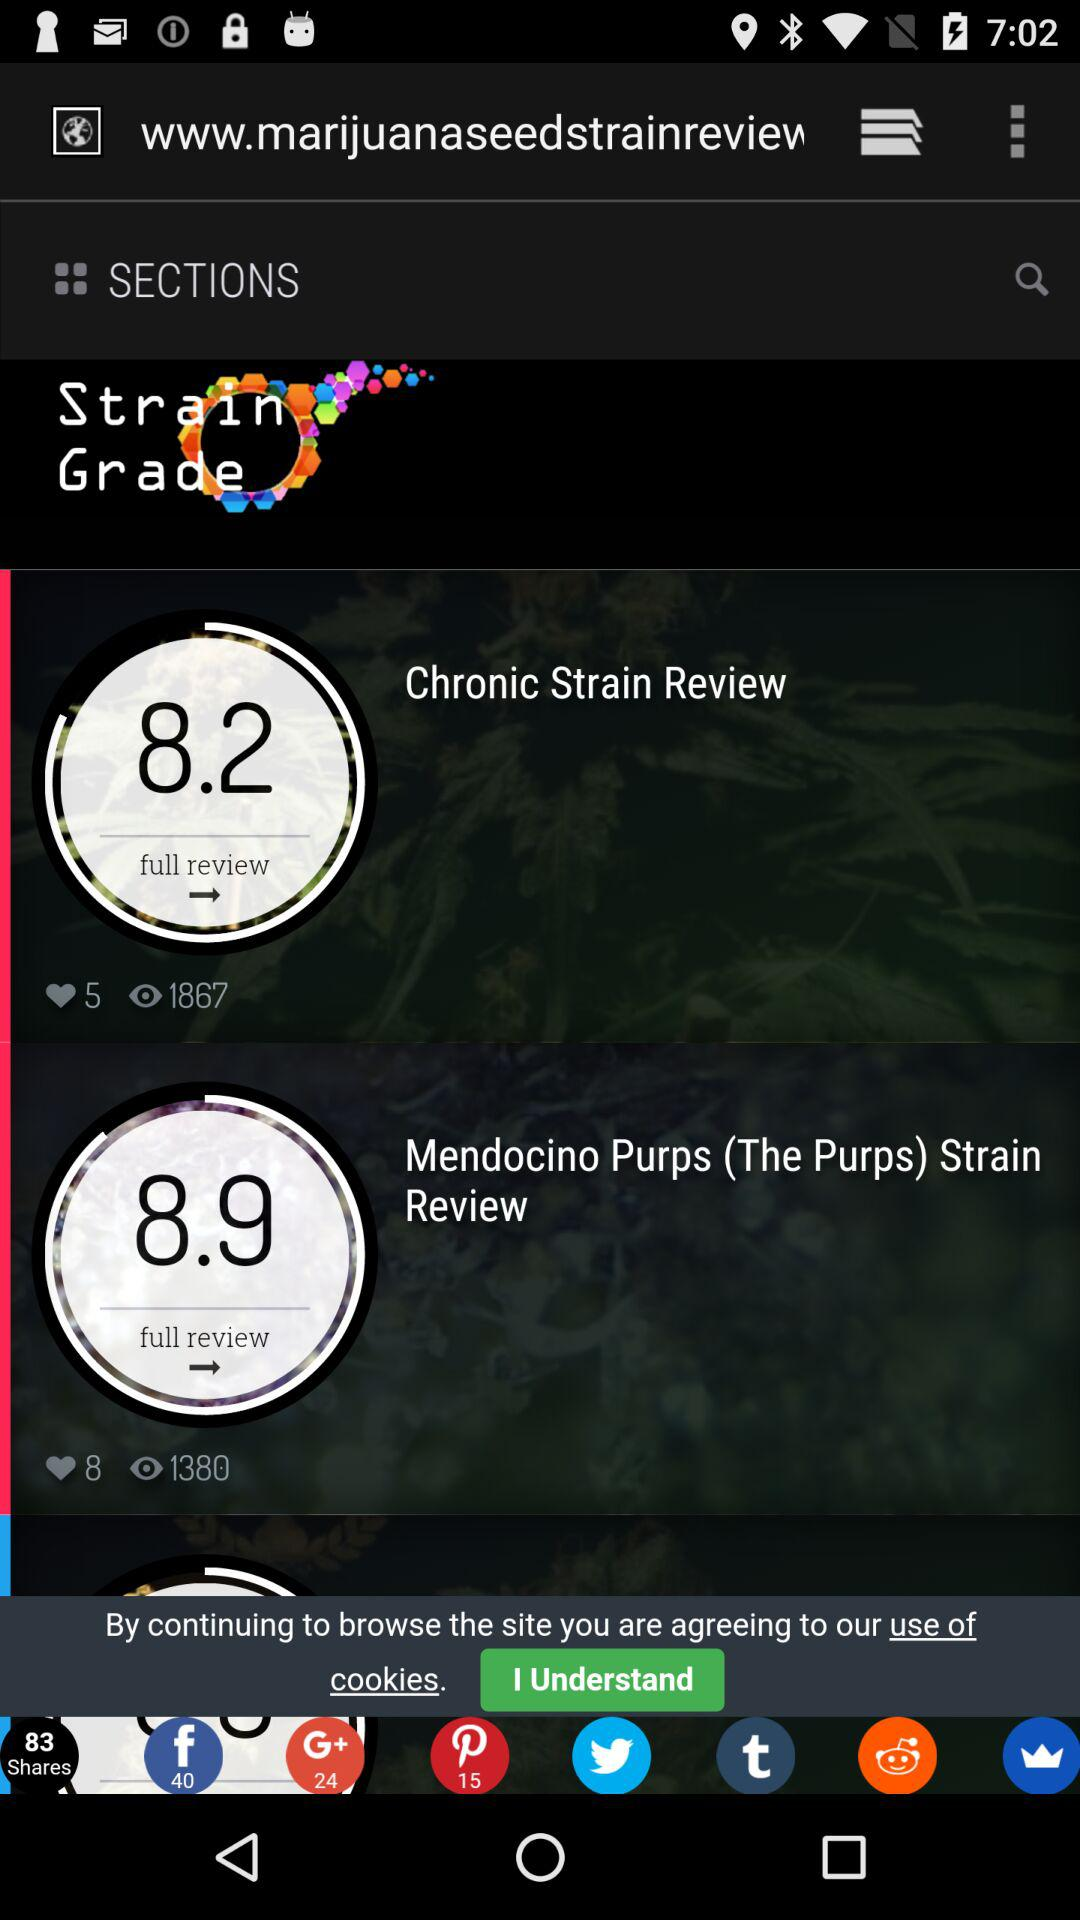What is the rating for the chronic strain review? The rating is 8.2. 